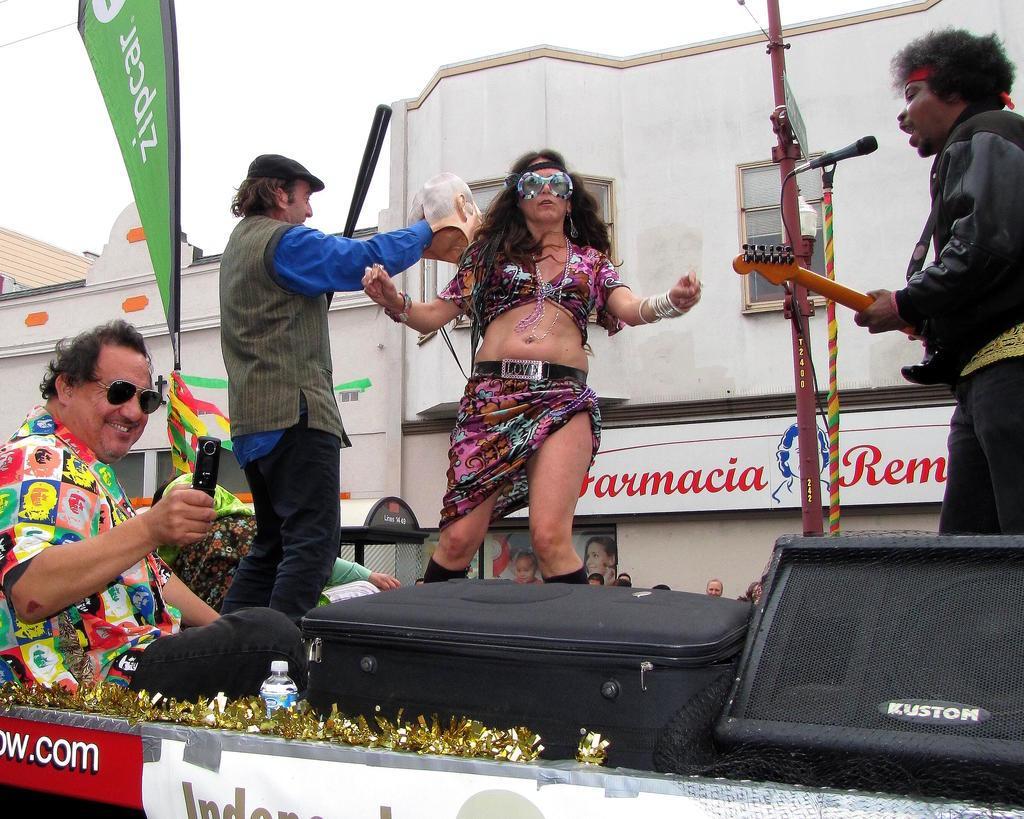Describe this image in one or two sentences. Here in this picture in the middle we can see a woman dancing over there and on the right side we can see a person playing a guitar and singing a song with a microphone present in front of him over there and on the left side we can see another person dancing in front of her and we can see another person sitting over there with a mobile phone in his hand and we can see he is smiling and wearing goggles on him and beside him we can see bottle of water, a luggage bag and a speaker present over there and we can also see a flag post present and behind them we can see building and stores present over there. 